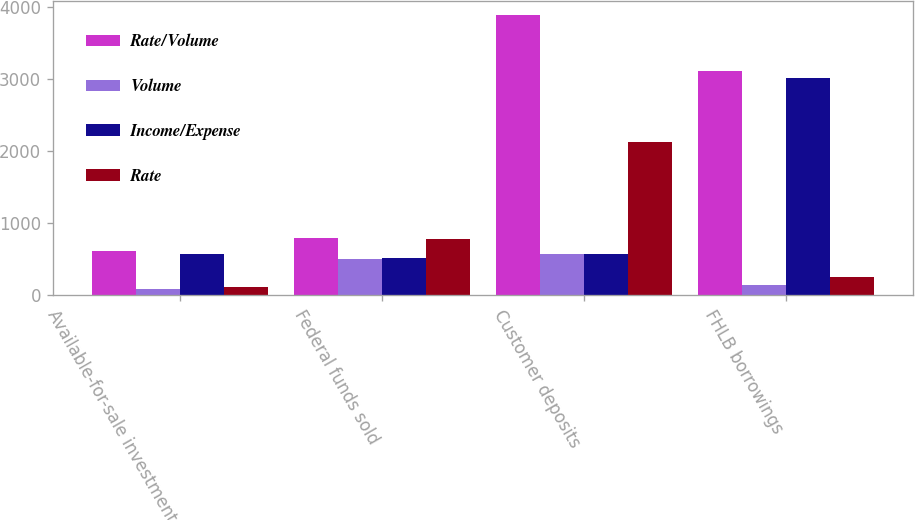Convert chart. <chart><loc_0><loc_0><loc_500><loc_500><stacked_bar_chart><ecel><fcel>Available-for-sale investment<fcel>Federal funds sold<fcel>Customer deposits<fcel>FHLB borrowings<nl><fcel>Rate/Volume<fcel>611<fcel>792<fcel>3895<fcel>3116<nl><fcel>Volume<fcel>86<fcel>500<fcel>573<fcel>149<nl><fcel>Income/Expense<fcel>580<fcel>515<fcel>580<fcel>3013<nl><fcel>Rate<fcel>117<fcel>777<fcel>2135<fcel>252<nl></chart> 